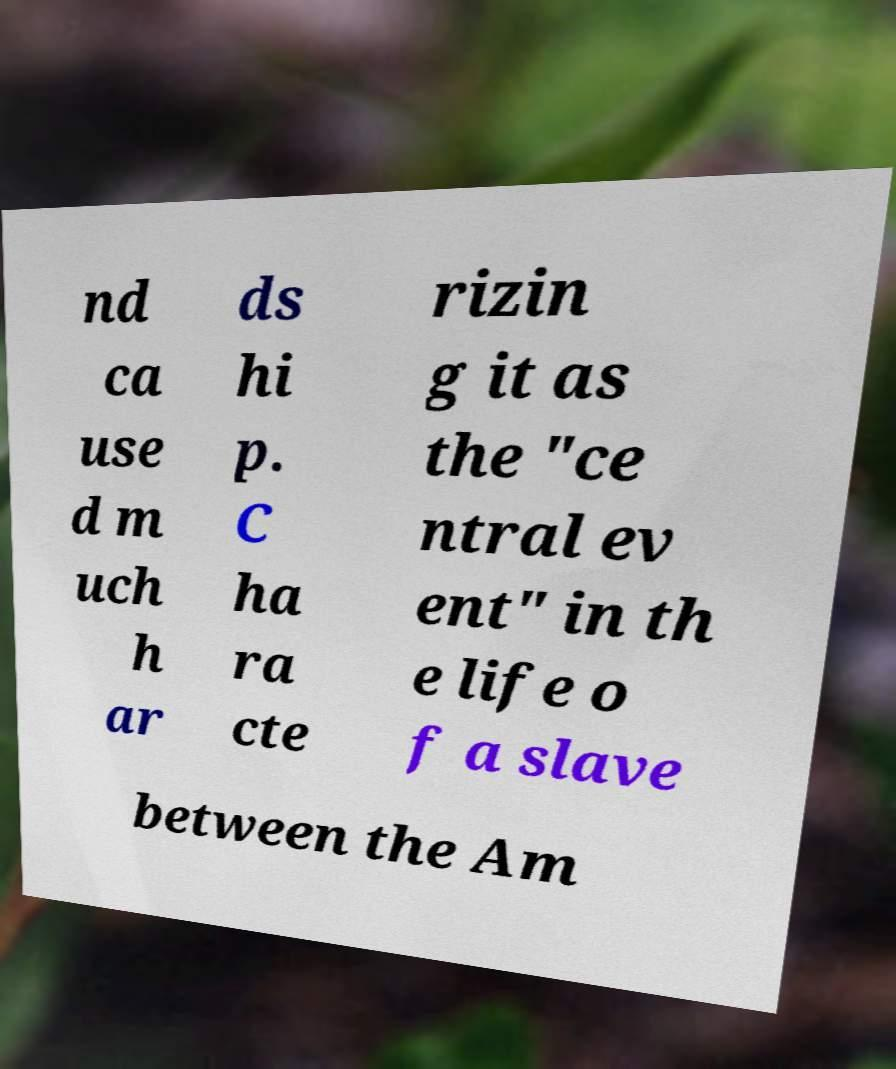Please read and relay the text visible in this image. What does it say? nd ca use d m uch h ar ds hi p. C ha ra cte rizin g it as the "ce ntral ev ent" in th e life o f a slave between the Am 